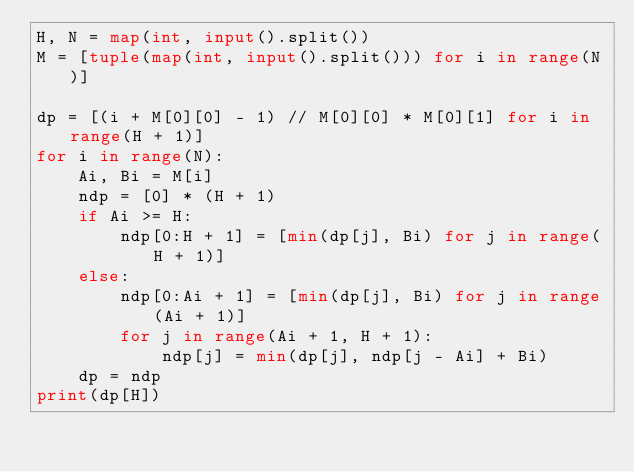Convert code to text. <code><loc_0><loc_0><loc_500><loc_500><_Python_>H, N = map(int, input().split())
M = [tuple(map(int, input().split())) for i in range(N)]

dp = [(i + M[0][0] - 1) // M[0][0] * M[0][1] for i in range(H + 1)]
for i in range(N):
    Ai, Bi = M[i]
    ndp = [0] * (H + 1)
    if Ai >= H:
        ndp[0:H + 1] = [min(dp[j], Bi) for j in range(H + 1)]
    else:
        ndp[0:Ai + 1] = [min(dp[j], Bi) for j in range(Ai + 1)]
        for j in range(Ai + 1, H + 1):
            ndp[j] = min(dp[j], ndp[j - Ai] + Bi)
    dp = ndp
print(dp[H])
</code> 